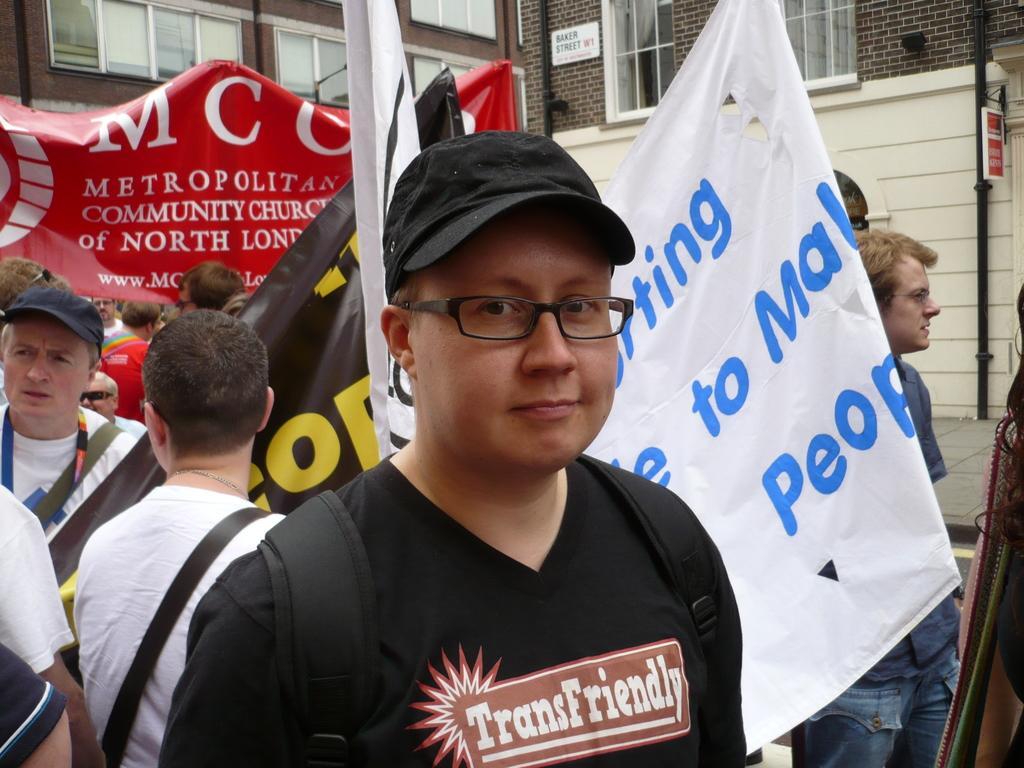Describe this image in one or two sentences. In this picture, in the middle, we can see a man wearing a backpack. On the right side, we can see group of people, hoardings. On the left side, we can also see a group of people. In the background, we can also see group of people, hoardings, buildings, glass windows. 